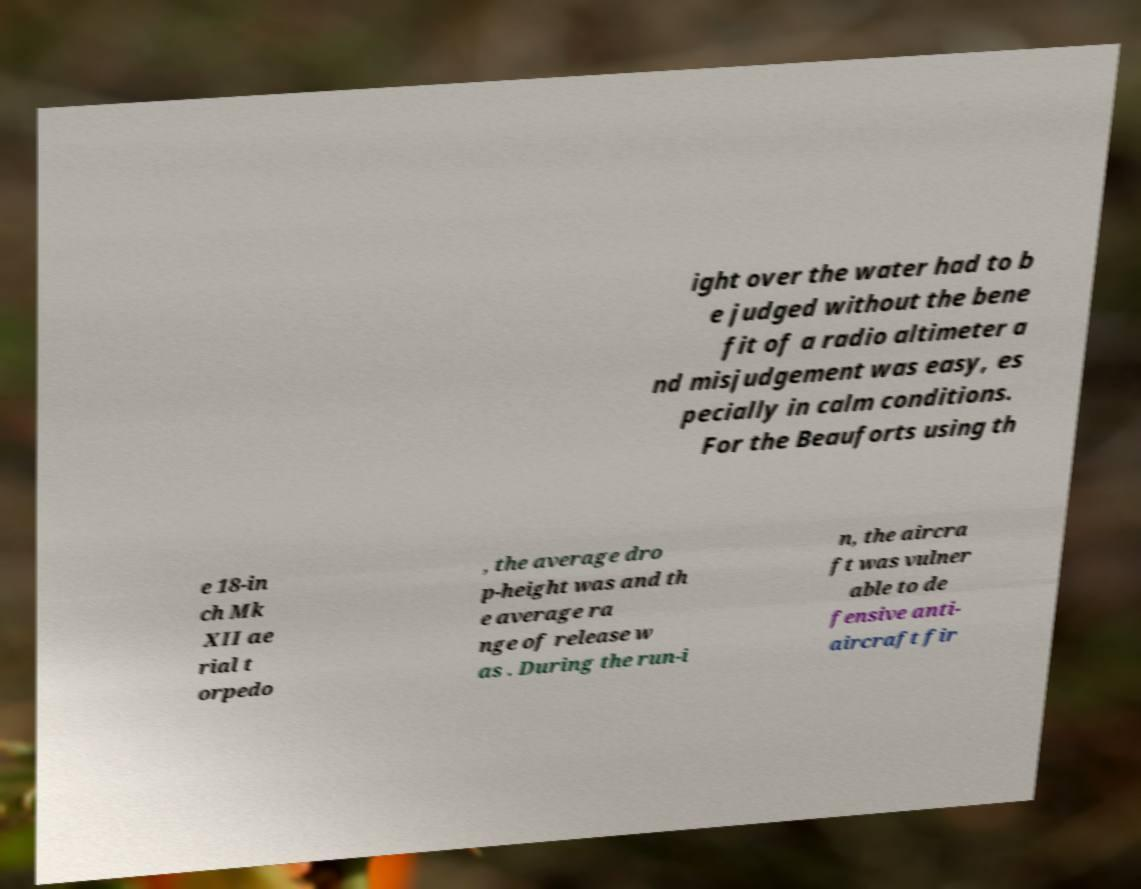Can you accurately transcribe the text from the provided image for me? ight over the water had to b e judged without the bene fit of a radio altimeter a nd misjudgement was easy, es pecially in calm conditions. For the Beauforts using th e 18-in ch Mk XII ae rial t orpedo , the average dro p-height was and th e average ra nge of release w as . During the run-i n, the aircra ft was vulner able to de fensive anti- aircraft fir 